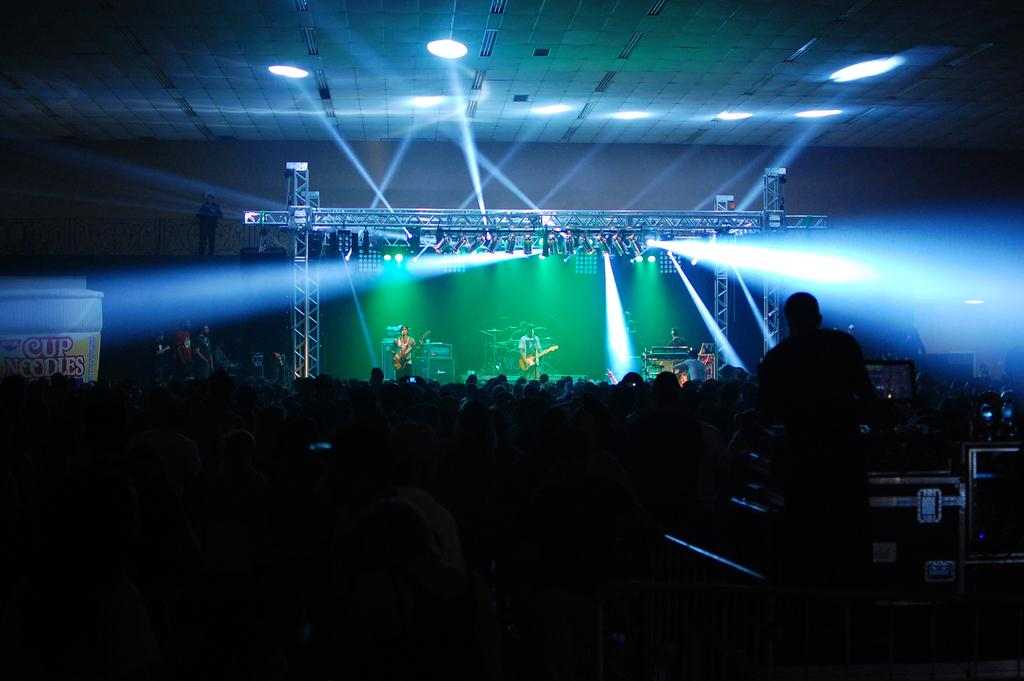What are the persons in the image doing on the dais? The persons in the image are performing on a dais. What can be seen at the bottom of the dais? There is a crowd at the bottom of the dais. What is visible in the background of the image? There are lights, persons, and a wall in the background of the image. Can you tell me where the father is sitting in the image? There is no mention of a father in the image, so we cannot determine where he might be sitting. What type of dirt is visible on the dais in the image? There is no dirt visible on the dais in the image; it appears to be a clean performance area. 